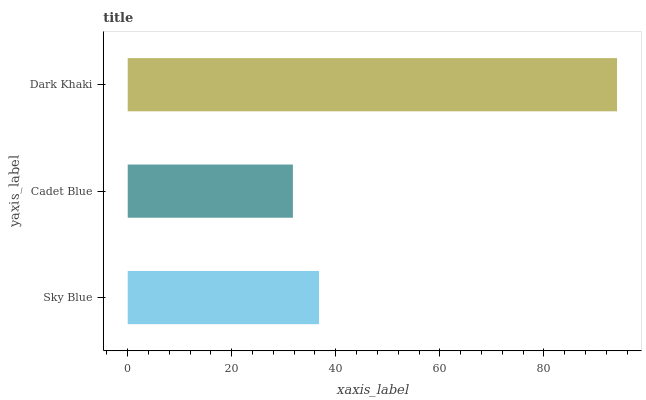Is Cadet Blue the minimum?
Answer yes or no. Yes. Is Dark Khaki the maximum?
Answer yes or no. Yes. Is Dark Khaki the minimum?
Answer yes or no. No. Is Cadet Blue the maximum?
Answer yes or no. No. Is Dark Khaki greater than Cadet Blue?
Answer yes or no. Yes. Is Cadet Blue less than Dark Khaki?
Answer yes or no. Yes. Is Cadet Blue greater than Dark Khaki?
Answer yes or no. No. Is Dark Khaki less than Cadet Blue?
Answer yes or no. No. Is Sky Blue the high median?
Answer yes or no. Yes. Is Sky Blue the low median?
Answer yes or no. Yes. Is Dark Khaki the high median?
Answer yes or no. No. Is Dark Khaki the low median?
Answer yes or no. No. 